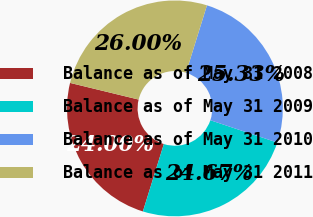Convert chart to OTSL. <chart><loc_0><loc_0><loc_500><loc_500><pie_chart><fcel>Balance as of May 31 2008<fcel>Balance as of May 31 2009<fcel>Balance as of May 31 2010<fcel>Balance as of May 31 2011<nl><fcel>24.0%<fcel>24.67%<fcel>25.33%<fcel>26.0%<nl></chart> 